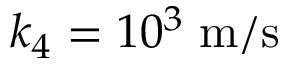Convert formula to latex. <formula><loc_0><loc_0><loc_500><loc_500>k _ { 4 } = 1 0 ^ { 3 } \, m / s</formula> 